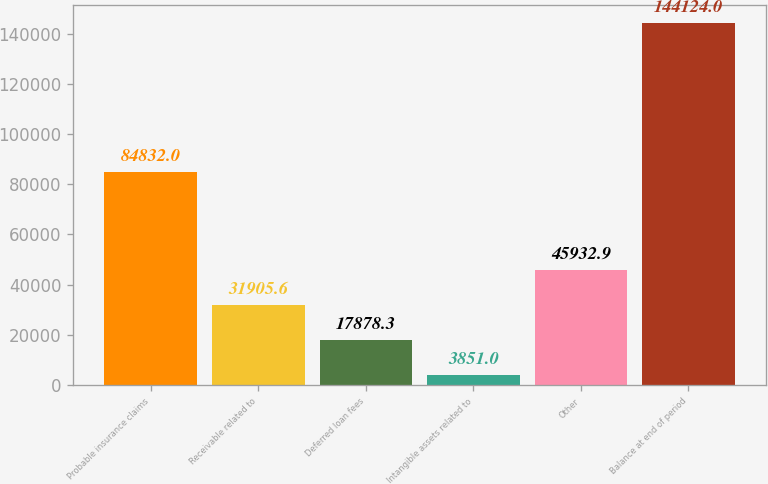<chart> <loc_0><loc_0><loc_500><loc_500><bar_chart><fcel>Probable insurance claims<fcel>Receivable related to<fcel>Deferred loan fees<fcel>Intangible assets related to<fcel>Other<fcel>Balance at end of period<nl><fcel>84832<fcel>31905.6<fcel>17878.3<fcel>3851<fcel>45932.9<fcel>144124<nl></chart> 